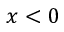<formula> <loc_0><loc_0><loc_500><loc_500>x < 0</formula> 